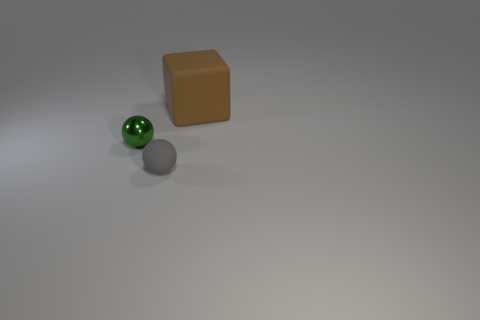What number of objects are either large blocks behind the metal ball or small spheres in front of the tiny shiny ball?
Make the answer very short. 2. What number of objects are either gray matte things or rubber objects behind the gray rubber thing?
Offer a terse response. 2. There is a matte thing on the right side of the rubber object on the left side of the rubber thing on the right side of the tiny gray matte object; what size is it?
Keep it short and to the point. Large. There is a green object that is the same size as the gray ball; what material is it?
Give a very brief answer. Metal. Is there a green metallic object that has the same size as the brown matte thing?
Make the answer very short. No. There is a rubber thing to the left of the brown thing; does it have the same size as the green metal ball?
Make the answer very short. Yes. There is a object that is both to the right of the small green shiny thing and behind the gray ball; what is its shape?
Offer a terse response. Cube. Is the number of gray spheres that are left of the small gray thing greater than the number of tiny green metallic objects?
Offer a very short reply. No. There is a gray ball that is the same material as the big brown block; what is its size?
Provide a succinct answer. Small. How many other small objects are the same color as the small rubber thing?
Keep it short and to the point. 0. 